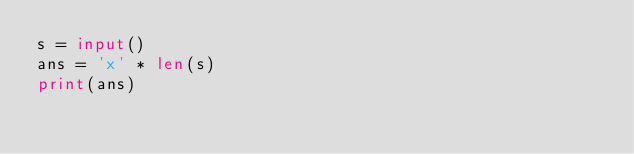Convert code to text. <code><loc_0><loc_0><loc_500><loc_500><_Python_>s = input()
ans = 'x' * len(s)
print(ans)</code> 